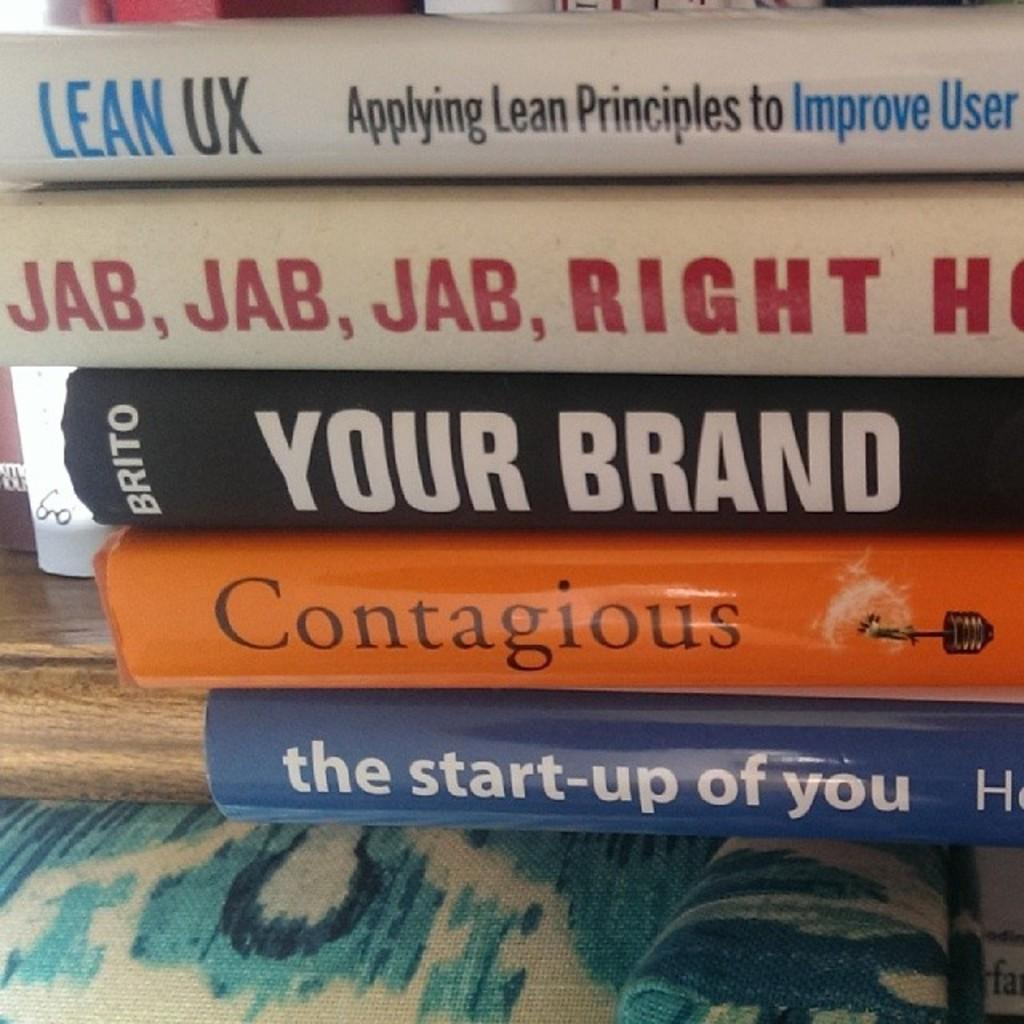<image>
Provide a brief description of the given image. A stack of books including Your Brand and Contagious. 